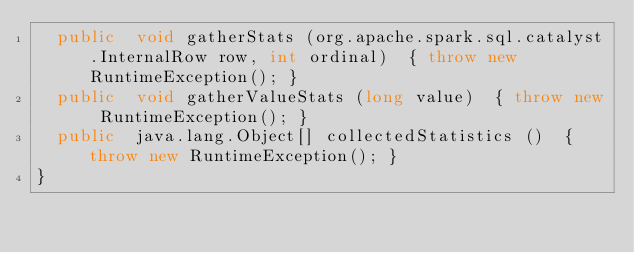Convert code to text. <code><loc_0><loc_0><loc_500><loc_500><_Java_>  public  void gatherStats (org.apache.spark.sql.catalyst.InternalRow row, int ordinal)  { throw new RuntimeException(); }
  public  void gatherValueStats (long value)  { throw new RuntimeException(); }
  public  java.lang.Object[] collectedStatistics ()  { throw new RuntimeException(); }
}
</code> 